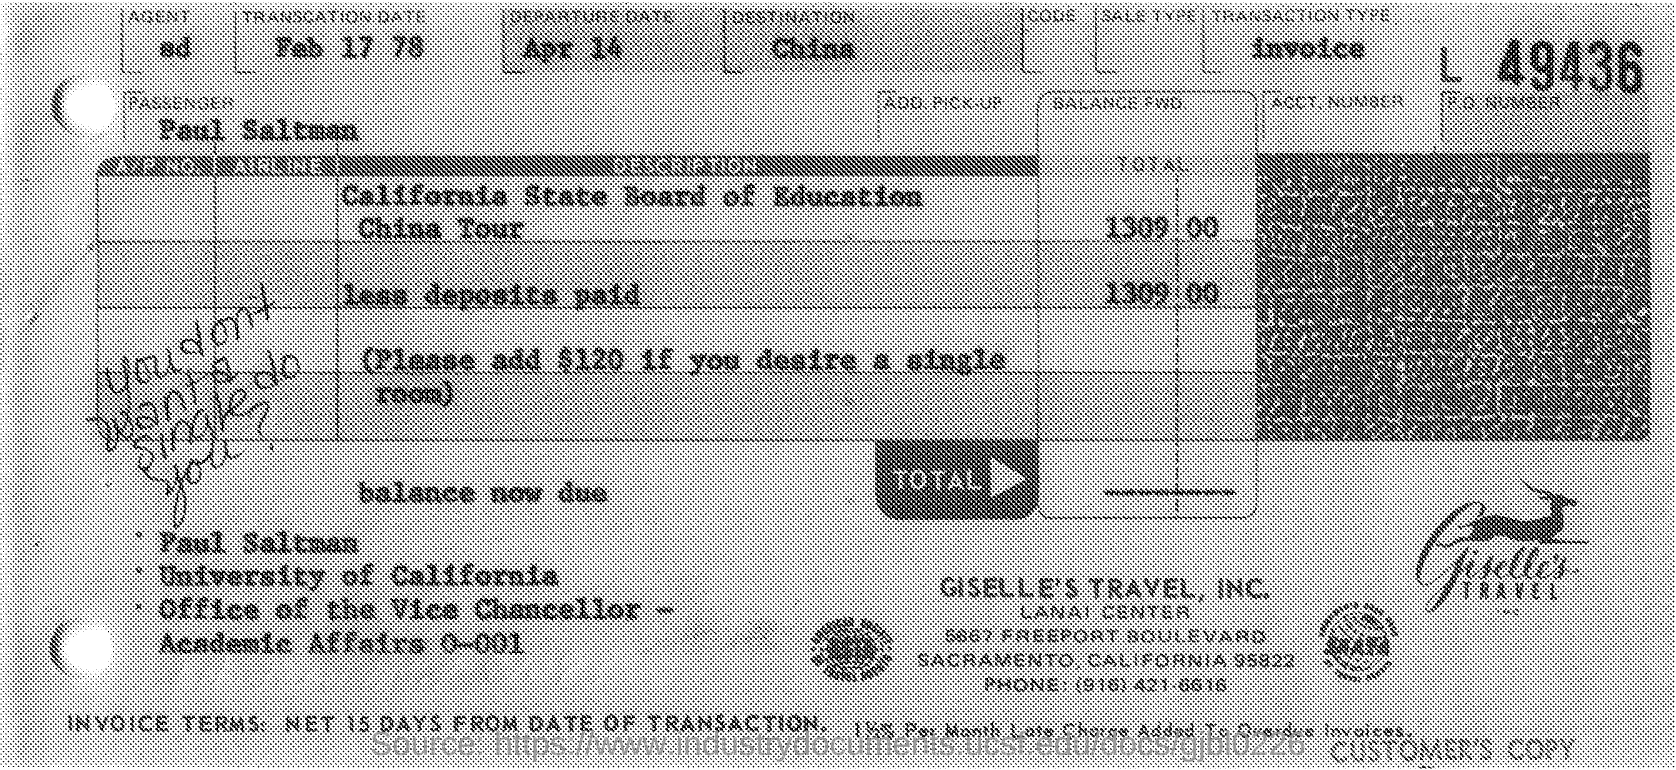Point out several critical features in this image. The passenger mentioned in the given page is Paul Saltman. The travel mentioned in the given page is Giselle's Travel, Inc. The transaction date mentioned on the given page is February 17, 1978. The departure date mentioned on the given page is April 14th. The given page mentions the place of destination as China. 